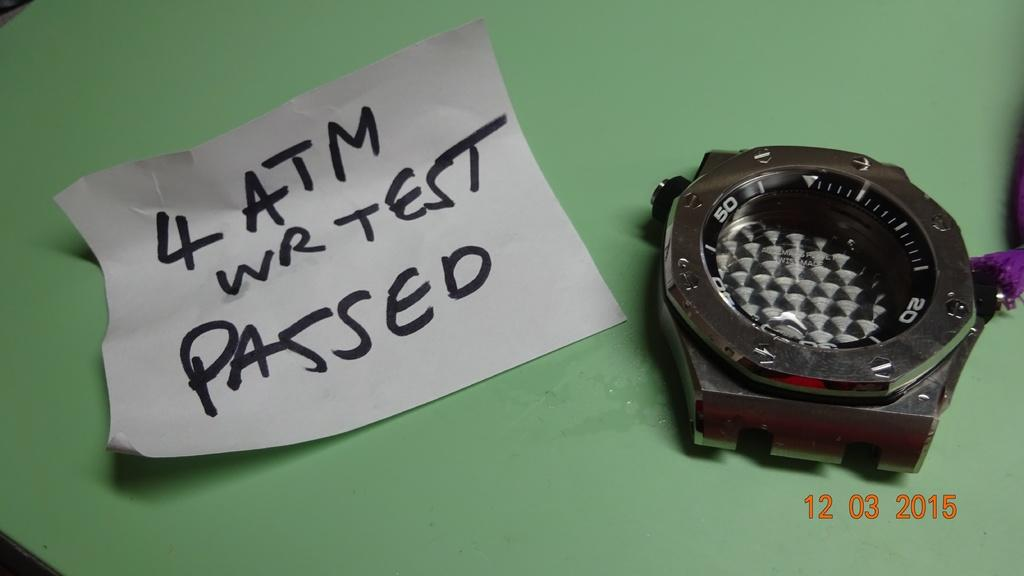<image>
Share a concise interpretation of the image provided. A picture of that was taken on March 12, 2015 with a note that says 4 ATM wr test passed. 